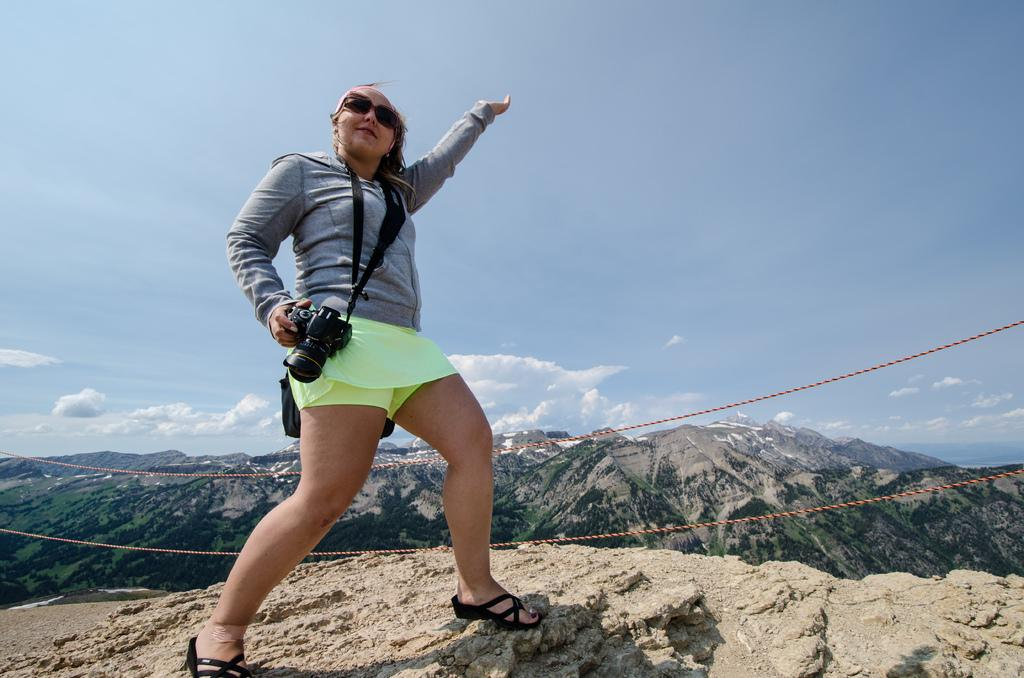Who is present in the image? There is a woman in the picture. What is the woman doing in the image? The woman is standing on a hill. What is the woman holding in the image? The woman is holding a camera. What is the woman wearing in the image? The woman is wearing spectacles. What can be seen in the background of the image? There are ropes and hills visible in the background, along with the sky and some clouds. What type of fowl can be seen interacting with the woman in the image? There is no fowl present in the image; the woman is standing alone on a hill. How many worms are visible on the ground near the woman in the image? There are no worms visible on the ground in the image. 